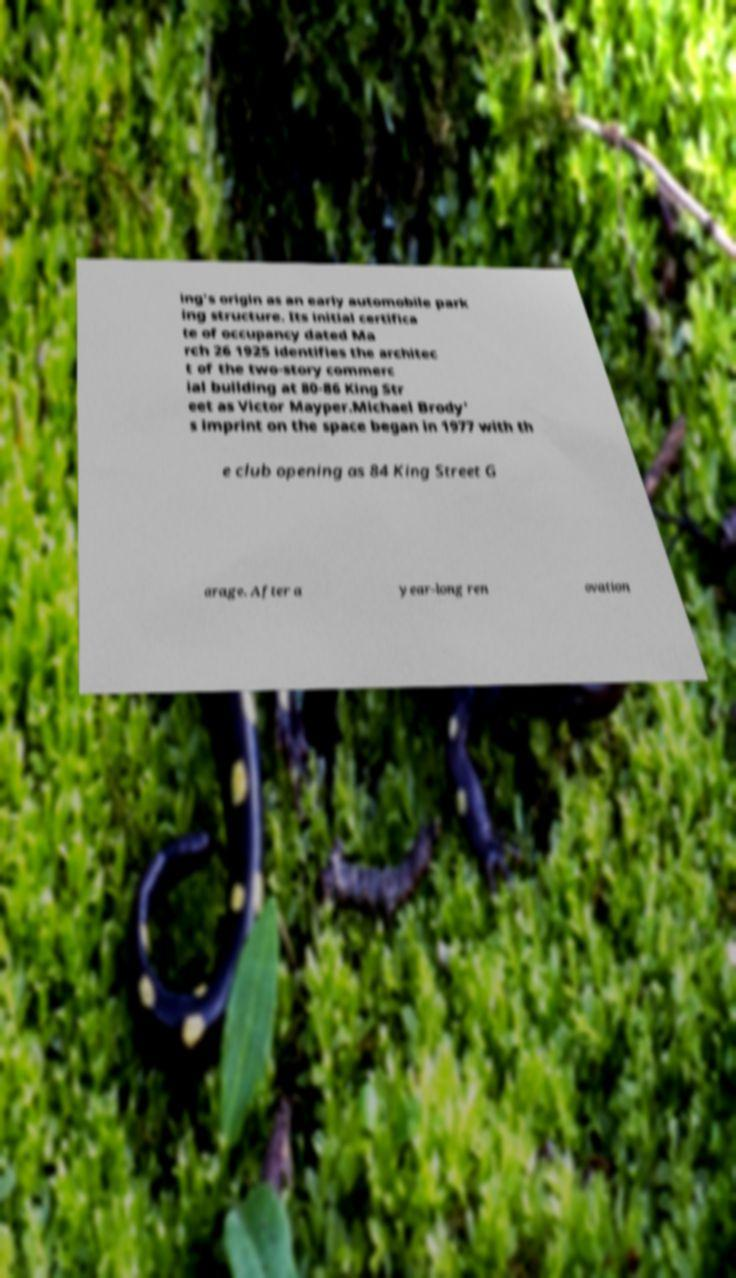Please identify and transcribe the text found in this image. ing's origin as an early automobile park ing structure. Its initial certifica te of occupancy dated Ma rch 26 1925 identifies the architec t of the two-story commerc ial building at 80-86 King Str eet as Victor Mayper.Michael Brody' s imprint on the space began in 1977 with th e club opening as 84 King Street G arage. After a year-long ren ovation 